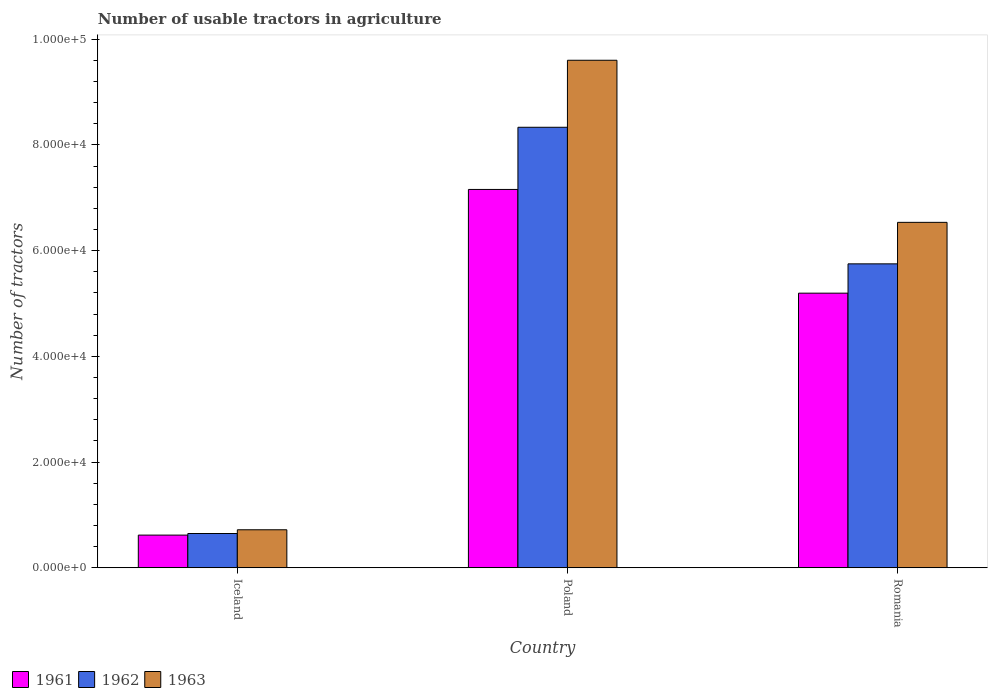Are the number of bars per tick equal to the number of legend labels?
Give a very brief answer. Yes. How many bars are there on the 2nd tick from the left?
Offer a very short reply. 3. What is the label of the 3rd group of bars from the left?
Offer a very short reply. Romania. In how many cases, is the number of bars for a given country not equal to the number of legend labels?
Give a very brief answer. 0. What is the number of usable tractors in agriculture in 1961 in Poland?
Offer a very short reply. 7.16e+04. Across all countries, what is the maximum number of usable tractors in agriculture in 1961?
Give a very brief answer. 7.16e+04. Across all countries, what is the minimum number of usable tractors in agriculture in 1961?
Your answer should be very brief. 6177. In which country was the number of usable tractors in agriculture in 1961 maximum?
Your response must be concise. Poland. What is the total number of usable tractors in agriculture in 1961 in the graph?
Keep it short and to the point. 1.30e+05. What is the difference between the number of usable tractors in agriculture in 1963 in Iceland and that in Poland?
Give a very brief answer. -8.88e+04. What is the difference between the number of usable tractors in agriculture in 1962 in Poland and the number of usable tractors in agriculture in 1963 in Romania?
Your response must be concise. 1.80e+04. What is the average number of usable tractors in agriculture in 1963 per country?
Keep it short and to the point. 5.62e+04. What is the difference between the number of usable tractors in agriculture of/in 1962 and number of usable tractors in agriculture of/in 1961 in Romania?
Your response must be concise. 5548. In how many countries, is the number of usable tractors in agriculture in 1963 greater than 16000?
Offer a terse response. 2. What is the ratio of the number of usable tractors in agriculture in 1962 in Iceland to that in Poland?
Offer a terse response. 0.08. What is the difference between the highest and the second highest number of usable tractors in agriculture in 1961?
Offer a terse response. -1.96e+04. What is the difference between the highest and the lowest number of usable tractors in agriculture in 1962?
Your response must be concise. 7.69e+04. In how many countries, is the number of usable tractors in agriculture in 1962 greater than the average number of usable tractors in agriculture in 1962 taken over all countries?
Provide a succinct answer. 2. Is the sum of the number of usable tractors in agriculture in 1961 in Iceland and Poland greater than the maximum number of usable tractors in agriculture in 1962 across all countries?
Offer a very short reply. No. What does the 1st bar from the left in Iceland represents?
Ensure brevity in your answer.  1961. How many countries are there in the graph?
Your answer should be very brief. 3. Are the values on the major ticks of Y-axis written in scientific E-notation?
Your answer should be compact. Yes. How many legend labels are there?
Make the answer very short. 3. How are the legend labels stacked?
Offer a terse response. Horizontal. What is the title of the graph?
Ensure brevity in your answer.  Number of usable tractors in agriculture. Does "2002" appear as one of the legend labels in the graph?
Provide a succinct answer. No. What is the label or title of the X-axis?
Make the answer very short. Country. What is the label or title of the Y-axis?
Your response must be concise. Number of tractors. What is the Number of tractors in 1961 in Iceland?
Offer a very short reply. 6177. What is the Number of tractors in 1962 in Iceland?
Provide a succinct answer. 6479. What is the Number of tractors in 1963 in Iceland?
Provide a succinct answer. 7187. What is the Number of tractors in 1961 in Poland?
Offer a very short reply. 7.16e+04. What is the Number of tractors in 1962 in Poland?
Provide a short and direct response. 8.33e+04. What is the Number of tractors in 1963 in Poland?
Give a very brief answer. 9.60e+04. What is the Number of tractors in 1961 in Romania?
Offer a very short reply. 5.20e+04. What is the Number of tractors of 1962 in Romania?
Give a very brief answer. 5.75e+04. What is the Number of tractors of 1963 in Romania?
Offer a terse response. 6.54e+04. Across all countries, what is the maximum Number of tractors in 1961?
Your answer should be very brief. 7.16e+04. Across all countries, what is the maximum Number of tractors in 1962?
Your answer should be compact. 8.33e+04. Across all countries, what is the maximum Number of tractors in 1963?
Provide a succinct answer. 9.60e+04. Across all countries, what is the minimum Number of tractors of 1961?
Your answer should be compact. 6177. Across all countries, what is the minimum Number of tractors of 1962?
Give a very brief answer. 6479. Across all countries, what is the minimum Number of tractors of 1963?
Ensure brevity in your answer.  7187. What is the total Number of tractors of 1961 in the graph?
Make the answer very short. 1.30e+05. What is the total Number of tractors in 1962 in the graph?
Offer a terse response. 1.47e+05. What is the total Number of tractors in 1963 in the graph?
Make the answer very short. 1.69e+05. What is the difference between the Number of tractors in 1961 in Iceland and that in Poland?
Offer a very short reply. -6.54e+04. What is the difference between the Number of tractors of 1962 in Iceland and that in Poland?
Keep it short and to the point. -7.69e+04. What is the difference between the Number of tractors in 1963 in Iceland and that in Poland?
Ensure brevity in your answer.  -8.88e+04. What is the difference between the Number of tractors in 1961 in Iceland and that in Romania?
Your response must be concise. -4.58e+04. What is the difference between the Number of tractors of 1962 in Iceland and that in Romania?
Your answer should be compact. -5.10e+04. What is the difference between the Number of tractors of 1963 in Iceland and that in Romania?
Your answer should be very brief. -5.82e+04. What is the difference between the Number of tractors of 1961 in Poland and that in Romania?
Offer a very short reply. 1.96e+04. What is the difference between the Number of tractors in 1962 in Poland and that in Romania?
Offer a very short reply. 2.58e+04. What is the difference between the Number of tractors in 1963 in Poland and that in Romania?
Offer a very short reply. 3.07e+04. What is the difference between the Number of tractors of 1961 in Iceland and the Number of tractors of 1962 in Poland?
Provide a succinct answer. -7.72e+04. What is the difference between the Number of tractors in 1961 in Iceland and the Number of tractors in 1963 in Poland?
Provide a short and direct response. -8.98e+04. What is the difference between the Number of tractors in 1962 in Iceland and the Number of tractors in 1963 in Poland?
Provide a succinct answer. -8.95e+04. What is the difference between the Number of tractors of 1961 in Iceland and the Number of tractors of 1962 in Romania?
Provide a short and direct response. -5.13e+04. What is the difference between the Number of tractors in 1961 in Iceland and the Number of tractors in 1963 in Romania?
Keep it short and to the point. -5.92e+04. What is the difference between the Number of tractors in 1962 in Iceland and the Number of tractors in 1963 in Romania?
Provide a short and direct response. -5.89e+04. What is the difference between the Number of tractors in 1961 in Poland and the Number of tractors in 1962 in Romania?
Offer a terse response. 1.41e+04. What is the difference between the Number of tractors in 1961 in Poland and the Number of tractors in 1963 in Romania?
Make the answer very short. 6226. What is the difference between the Number of tractors of 1962 in Poland and the Number of tractors of 1963 in Romania?
Ensure brevity in your answer.  1.80e+04. What is the average Number of tractors in 1961 per country?
Ensure brevity in your answer.  4.32e+04. What is the average Number of tractors in 1962 per country?
Offer a very short reply. 4.91e+04. What is the average Number of tractors of 1963 per country?
Ensure brevity in your answer.  5.62e+04. What is the difference between the Number of tractors of 1961 and Number of tractors of 1962 in Iceland?
Ensure brevity in your answer.  -302. What is the difference between the Number of tractors of 1961 and Number of tractors of 1963 in Iceland?
Keep it short and to the point. -1010. What is the difference between the Number of tractors of 1962 and Number of tractors of 1963 in Iceland?
Keep it short and to the point. -708. What is the difference between the Number of tractors in 1961 and Number of tractors in 1962 in Poland?
Your answer should be compact. -1.18e+04. What is the difference between the Number of tractors of 1961 and Number of tractors of 1963 in Poland?
Make the answer very short. -2.44e+04. What is the difference between the Number of tractors in 1962 and Number of tractors in 1963 in Poland?
Provide a succinct answer. -1.27e+04. What is the difference between the Number of tractors of 1961 and Number of tractors of 1962 in Romania?
Your answer should be very brief. -5548. What is the difference between the Number of tractors of 1961 and Number of tractors of 1963 in Romania?
Provide a short and direct response. -1.34e+04. What is the difference between the Number of tractors in 1962 and Number of tractors in 1963 in Romania?
Offer a very short reply. -7851. What is the ratio of the Number of tractors of 1961 in Iceland to that in Poland?
Keep it short and to the point. 0.09. What is the ratio of the Number of tractors of 1962 in Iceland to that in Poland?
Offer a very short reply. 0.08. What is the ratio of the Number of tractors in 1963 in Iceland to that in Poland?
Your response must be concise. 0.07. What is the ratio of the Number of tractors in 1961 in Iceland to that in Romania?
Your answer should be very brief. 0.12. What is the ratio of the Number of tractors in 1962 in Iceland to that in Romania?
Offer a very short reply. 0.11. What is the ratio of the Number of tractors in 1963 in Iceland to that in Romania?
Offer a very short reply. 0.11. What is the ratio of the Number of tractors of 1961 in Poland to that in Romania?
Provide a short and direct response. 1.38. What is the ratio of the Number of tractors of 1962 in Poland to that in Romania?
Your response must be concise. 1.45. What is the ratio of the Number of tractors of 1963 in Poland to that in Romania?
Your answer should be compact. 1.47. What is the difference between the highest and the second highest Number of tractors of 1961?
Ensure brevity in your answer.  1.96e+04. What is the difference between the highest and the second highest Number of tractors of 1962?
Make the answer very short. 2.58e+04. What is the difference between the highest and the second highest Number of tractors of 1963?
Offer a very short reply. 3.07e+04. What is the difference between the highest and the lowest Number of tractors in 1961?
Offer a very short reply. 6.54e+04. What is the difference between the highest and the lowest Number of tractors of 1962?
Offer a terse response. 7.69e+04. What is the difference between the highest and the lowest Number of tractors of 1963?
Give a very brief answer. 8.88e+04. 